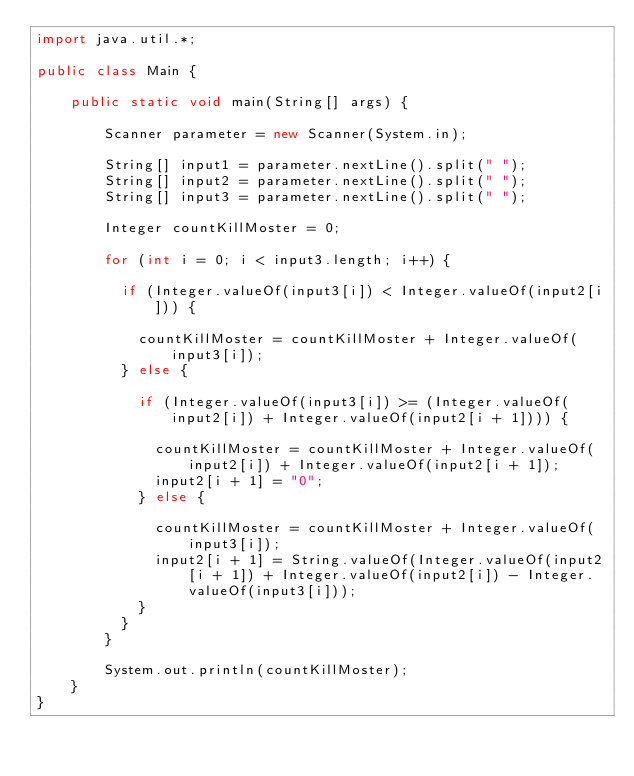Convert code to text. <code><loc_0><loc_0><loc_500><loc_500><_Java_>import java.util.*;

public class Main {

    public static void main(String[] args) {

        Scanner parameter = new Scanner(System.in);

        String[] input1 = parameter.nextLine().split(" ");
        String[] input2 = parameter.nextLine().split(" ");
        String[] input3 = parameter.nextLine().split(" ");

        Integer countKillMoster = 0;

        for (int i = 0; i < input3.length; i++) {

        	if (Integer.valueOf(input3[i]) < Integer.valueOf(input2[i])) {

        		countKillMoster = countKillMoster + Integer.valueOf(input3[i]);
        	} else {

        		if (Integer.valueOf(input3[i]) >= (Integer.valueOf(input2[i]) + Integer.valueOf(input2[i + 1]))) {

        			countKillMoster = countKillMoster + Integer.valueOf(input2[i]) + Integer.valueOf(input2[i + 1]);
        			input2[i + 1] = "0";
        		} else {

        			countKillMoster = countKillMoster + Integer.valueOf(input3[i]);
        			input2[i + 1] = String.valueOf(Integer.valueOf(input2[i + 1]) + Integer.valueOf(input2[i]) - Integer.valueOf(input3[i]));
        		}
        	}
        }

        System.out.println(countKillMoster);
    }
}
</code> 